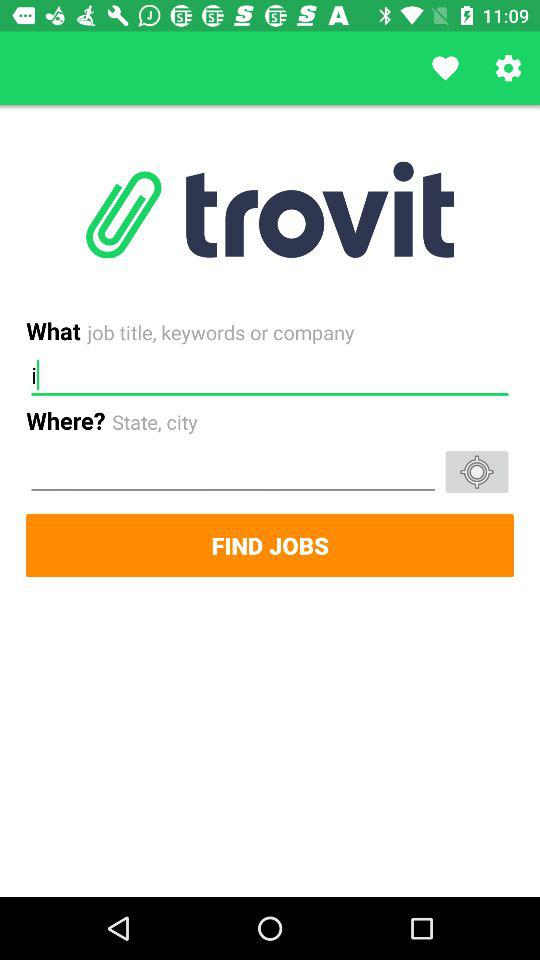What is the time of sunset? The sunset time is 18:51. 